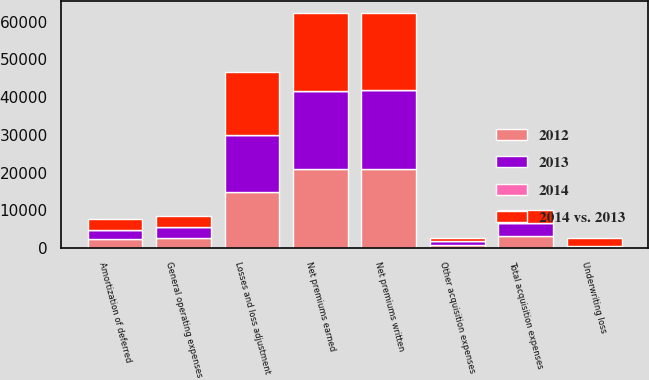Convert chart. <chart><loc_0><loc_0><loc_500><loc_500><stacked_bar_chart><ecel><fcel>Net premiums written<fcel>Net premiums earned<fcel>Losses and loss adjustment<fcel>Amortization of deferred<fcel>Other acquisition expenses<fcel>Total acquisition expenses<fcel>General operating expenses<fcel>Underwriting loss<nl><fcel>2012<fcel>21020<fcel>20885<fcel>14956<fcel>2486<fcel>796<fcel>3282<fcel>2697<fcel>50<nl><fcel>2013<fcel>20880<fcel>20677<fcel>14872<fcel>2394<fcel>937<fcel>3331<fcel>2810<fcel>336<nl><fcel>2014 vs. 2013<fcel>20348<fcel>20848<fcel>16779<fcel>2673<fcel>783<fcel>3456<fcel>2883<fcel>2270<nl><fcel>2014<fcel>1<fcel>1<fcel>1<fcel>4<fcel>15<fcel>1<fcel>4<fcel>85<nl></chart> 